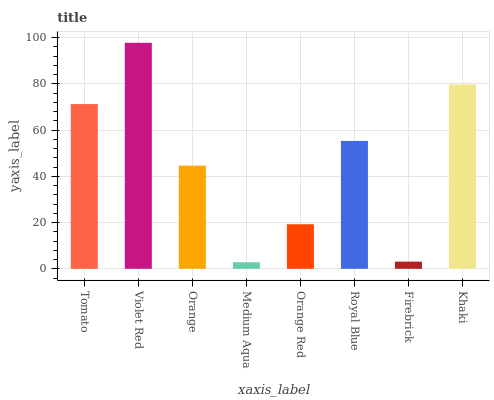Is Orange the minimum?
Answer yes or no. No. Is Orange the maximum?
Answer yes or no. No. Is Violet Red greater than Orange?
Answer yes or no. Yes. Is Orange less than Violet Red?
Answer yes or no. Yes. Is Orange greater than Violet Red?
Answer yes or no. No. Is Violet Red less than Orange?
Answer yes or no. No. Is Royal Blue the high median?
Answer yes or no. Yes. Is Orange the low median?
Answer yes or no. Yes. Is Medium Aqua the high median?
Answer yes or no. No. Is Khaki the low median?
Answer yes or no. No. 